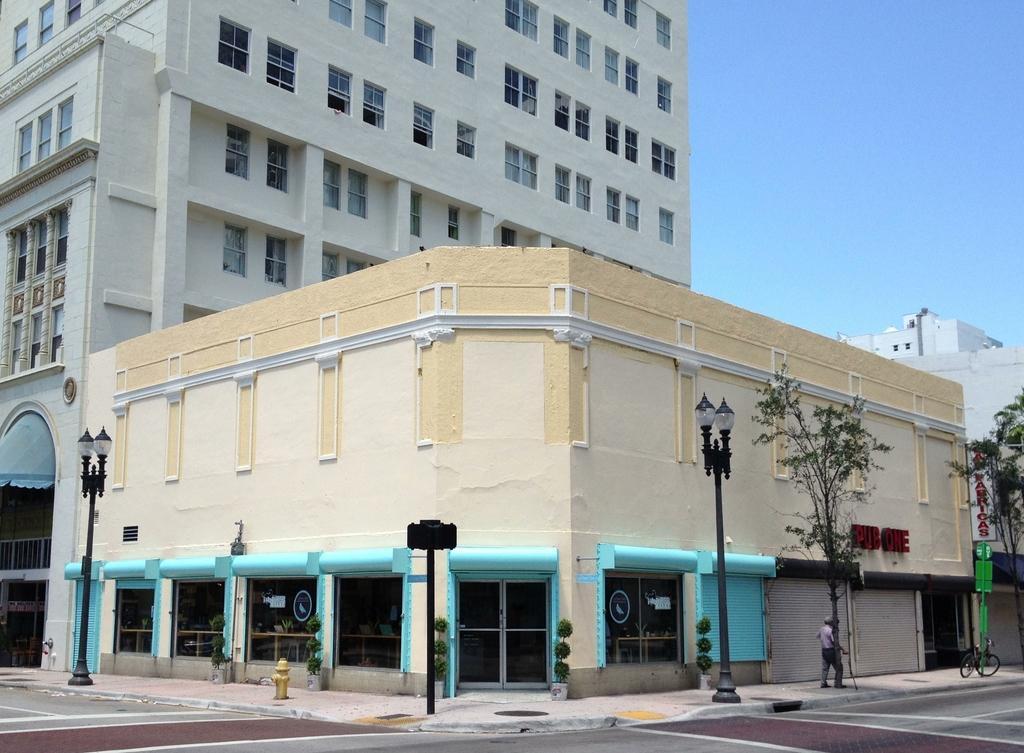Please provide a concise description of this image. In this picture we can see the road, footpath, hydrant, person, bicycle, poles, plants, shutters, buildings with windows, some objects and in the background we can see the sky. 